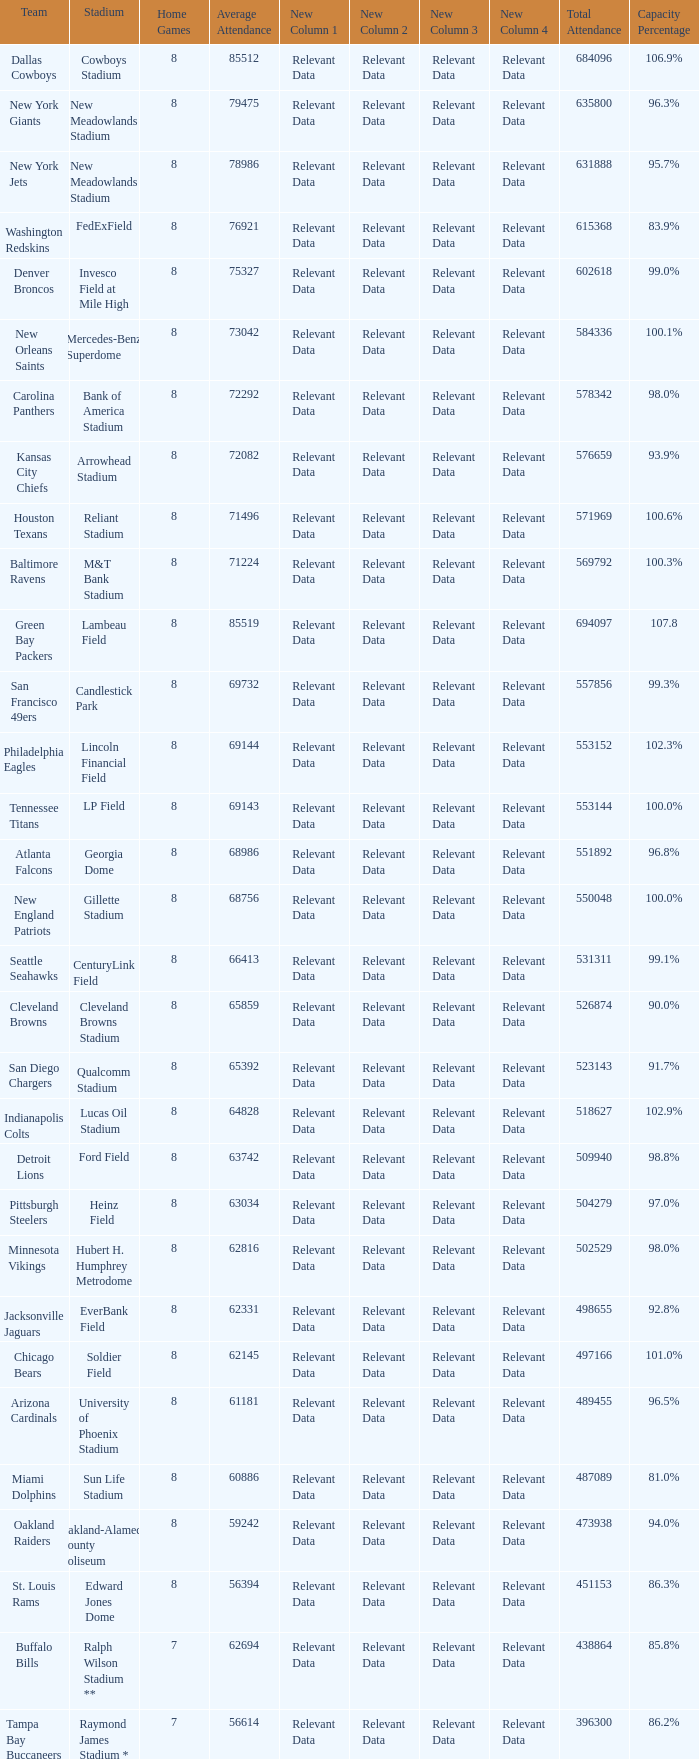What is the capacity percentage when the total attendance is 509940? 98.8%. 